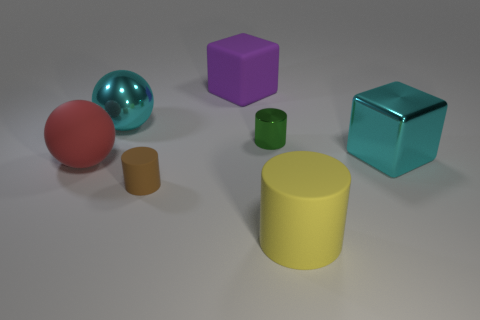Is the color of the metallic ball the same as the big metal cube?
Offer a terse response. Yes. What number of things are in front of the tiny matte cylinder?
Offer a terse response. 1. How many cylinders are both behind the red ball and on the left side of the purple cube?
Offer a very short reply. 0. There is a brown object that is made of the same material as the big red thing; what is its shape?
Give a very brief answer. Cylinder. There is a cylinder that is behind the big rubber sphere; is it the same size as the block that is to the right of the large yellow matte thing?
Your answer should be very brief. No. There is a small cylinder that is in front of the green metal cylinder; what color is it?
Ensure brevity in your answer.  Brown. What material is the large cyan thing that is behind the cyan object that is to the right of the brown matte thing made of?
Your answer should be very brief. Metal. What shape is the big purple object?
Offer a very short reply. Cube. What material is the green object that is the same shape as the large yellow matte thing?
Ensure brevity in your answer.  Metal. What number of metallic things are the same size as the metallic cylinder?
Keep it short and to the point. 0. 